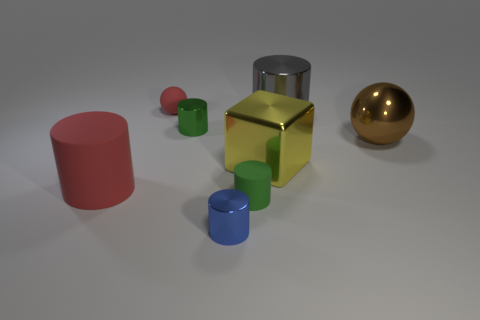Is there a brown matte ball that has the same size as the blue object?
Provide a succinct answer. No. There is a tiny cylinder left of the blue cylinder; what material is it?
Your answer should be very brief. Metal. Do the small green thing that is in front of the brown object and the small blue cylinder have the same material?
Ensure brevity in your answer.  No. The gray thing that is the same size as the yellow shiny block is what shape?
Ensure brevity in your answer.  Cylinder. What number of other matte cylinders are the same color as the big matte cylinder?
Keep it short and to the point. 0. Is the number of shiny objects on the left side of the tiny rubber cylinder less than the number of metallic cylinders that are behind the large brown sphere?
Keep it short and to the point. No. Are there any big matte things in front of the large matte cylinder?
Your answer should be very brief. No. Is there a tiny green rubber object that is on the left side of the red object in front of the tiny shiny cylinder that is behind the big cube?
Keep it short and to the point. No. There is a red matte thing behind the yellow block; does it have the same shape as the green shiny object?
Your response must be concise. No. What color is the large cylinder that is made of the same material as the tiny blue object?
Make the answer very short. Gray. 